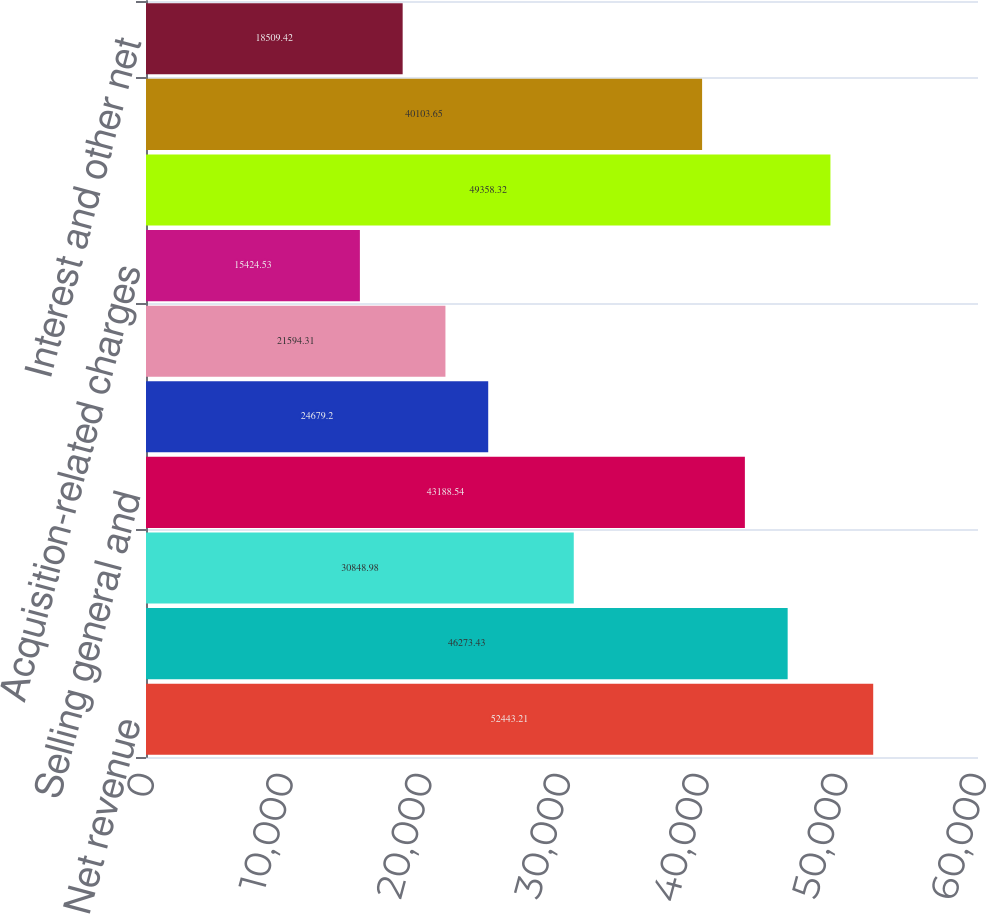<chart> <loc_0><loc_0><loc_500><loc_500><bar_chart><fcel>Net revenue<fcel>Cost of sales (1)<fcel>Research and development<fcel>Selling general and<fcel>Amortization of purchased<fcel>Restructuring charges<fcel>Acquisition-related charges<fcel>Total costs and expenses<fcel>Earnings from operations<fcel>Interest and other net<nl><fcel>52443.2<fcel>46273.4<fcel>30849<fcel>43188.5<fcel>24679.2<fcel>21594.3<fcel>15424.5<fcel>49358.3<fcel>40103.7<fcel>18509.4<nl></chart> 